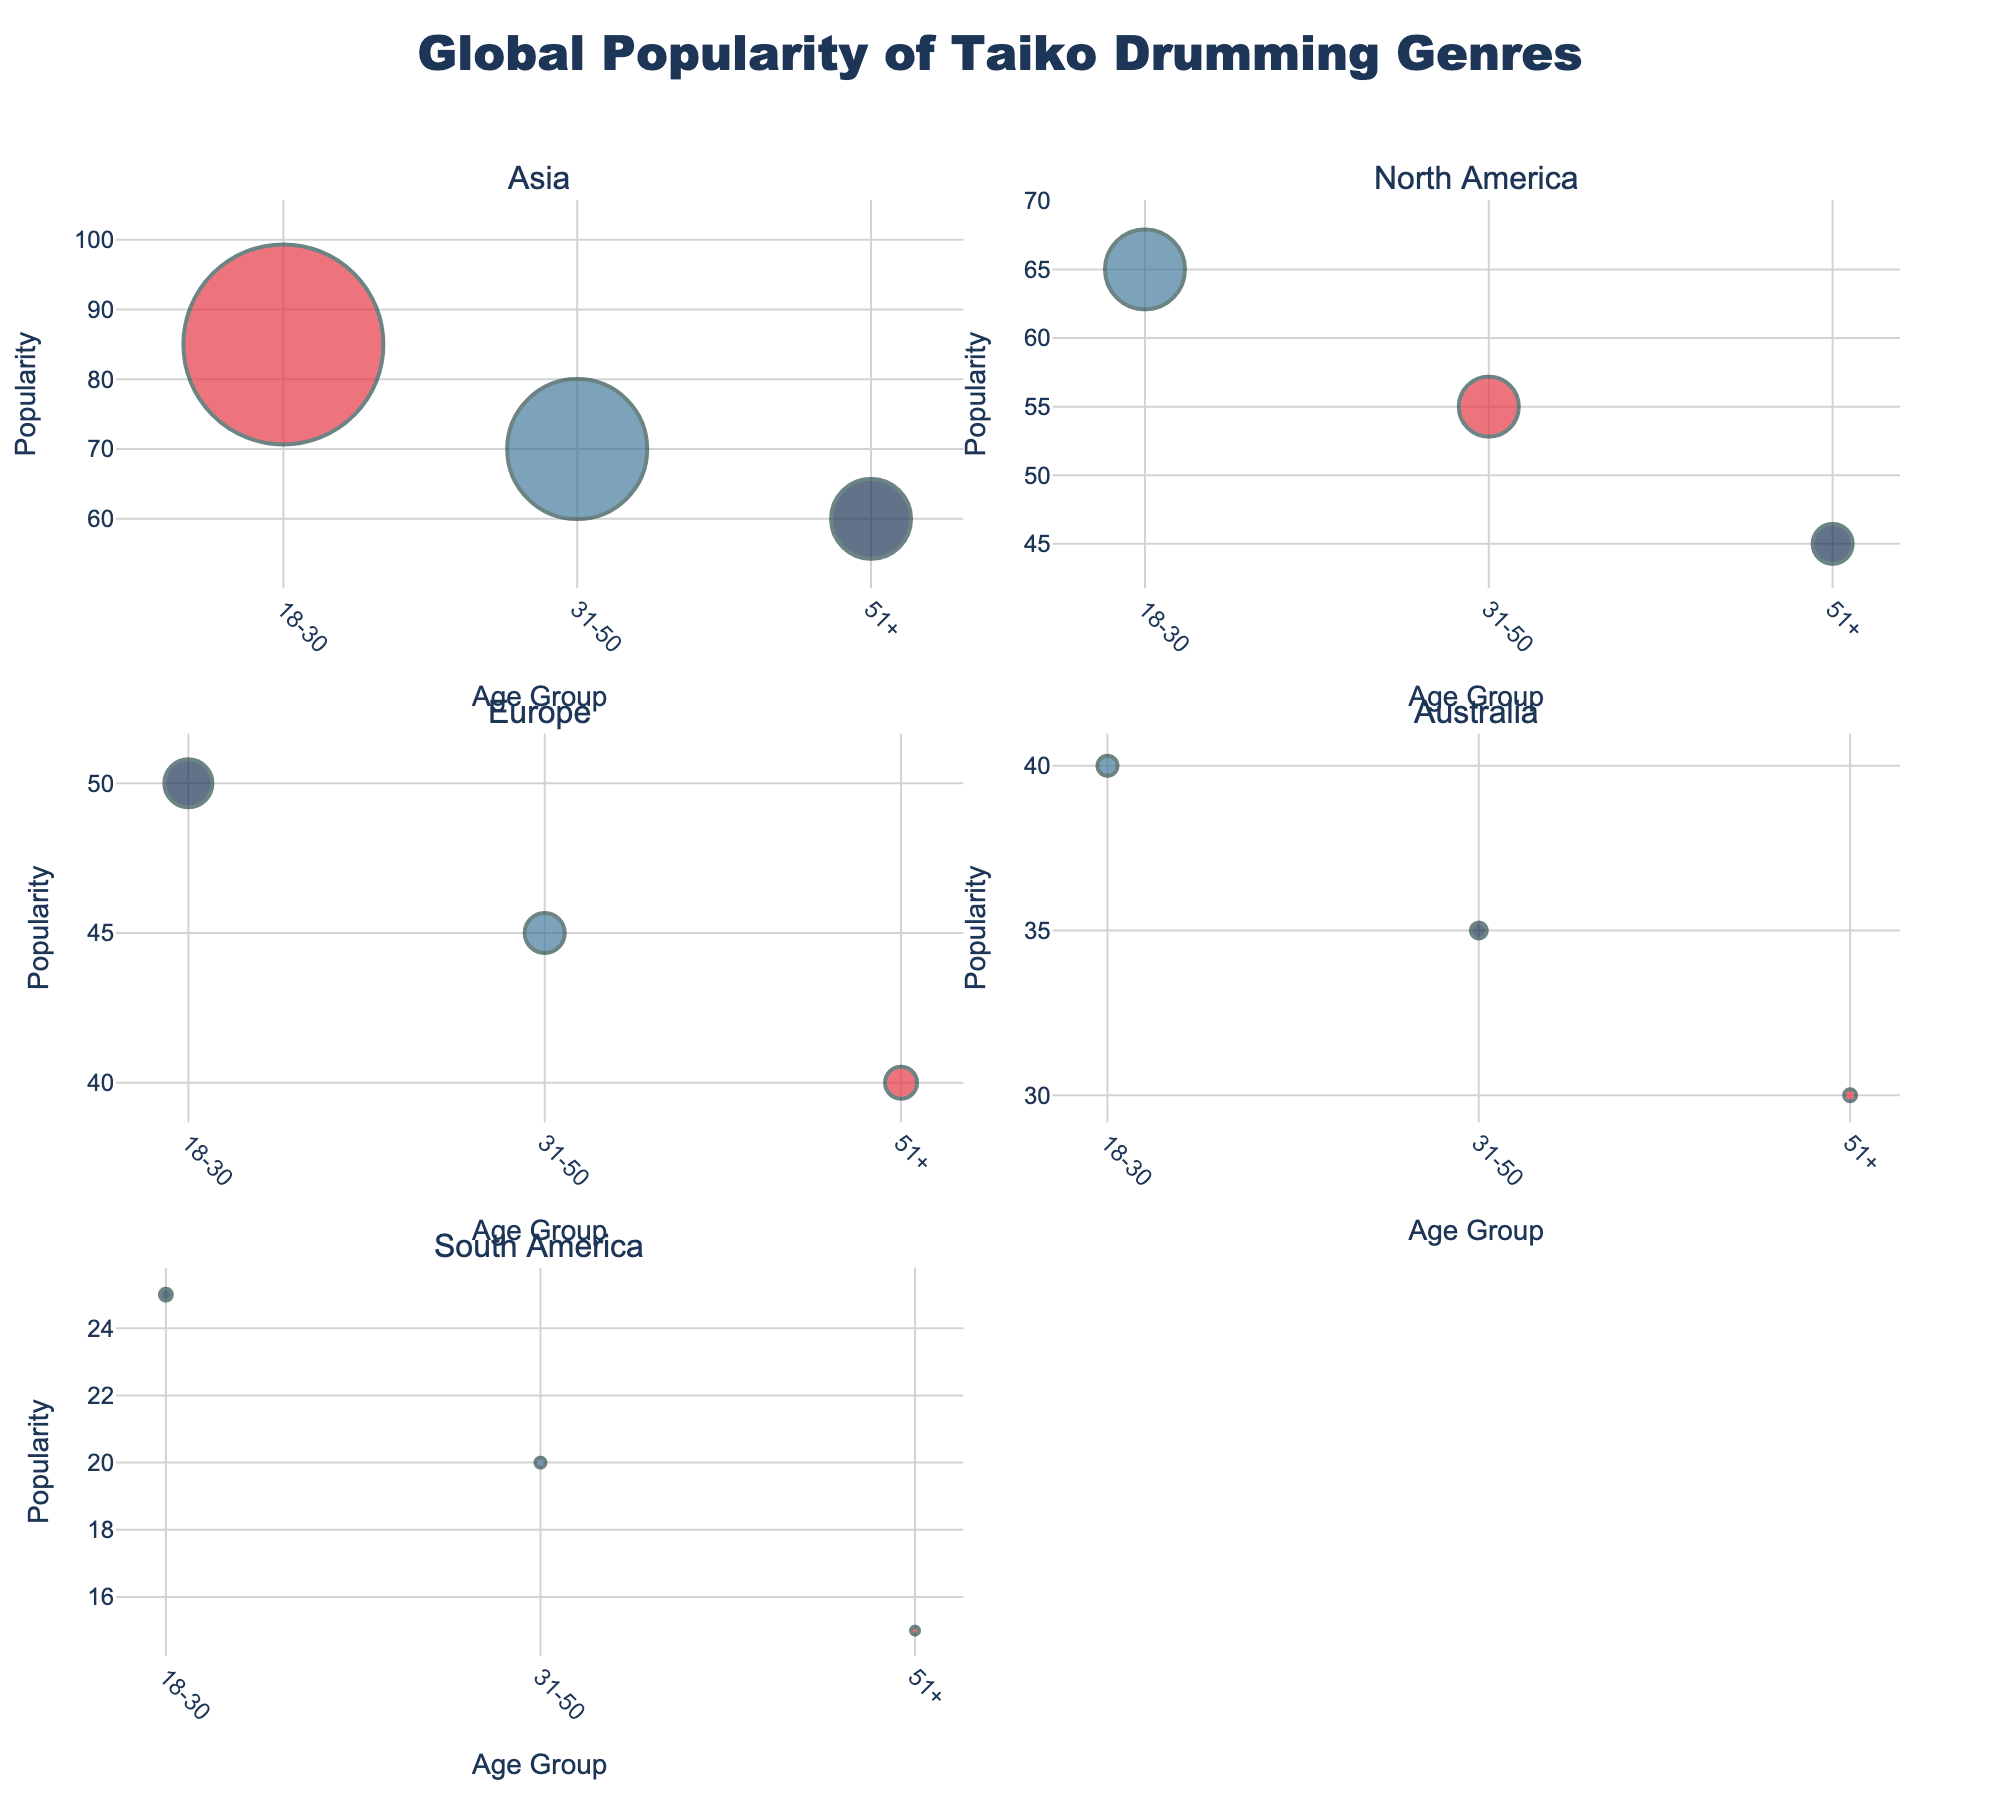What is the most popular taiko drumming genre among the 18-30 age group in Asia? The highest bubble in Asia for the 18-30 age group is marked with the color representing Traditional Taiko, with a popularity score of 85.
Answer: Traditional Taiko Which continent has the least popular taiko genre for the 51+ age group? The smallest bubble among the 51+ age groups is in South America with a popularity score of 15 for Traditional Taiko.
Answer: South America In which age group and continent is Fusion Taiko more popular than both Traditional Taiko and Contemporary Taiko? In the plot for North America for the 18-30 age group, Fusion Taiko is more popular than both Traditional Taiko and Contemporary Taiko, with a popularity score of 65.
Answer: North America, 18-30 How does the popularity of Traditional Taiko compare between Europe and Australia for the 31-50 age group? In the subplot for Europe for the 31-50 age group, Traditional Taiko is not present; however, in Australia, it has a popularity score of 30.
Answer: Higher in Europe What is the average audience size for all taiko genres in Asia? Summing the all audience sizes in Asia (5000000 + 3500000 + 2000000) gives 10500000, and averaging this by 3 gives: 10500000 / 3.
Answer: 3500000 Identify the continent where Contemporary Taiko is the most popular among all age groups. The highest bubble for Contemporary Taiko across all subplots is in Asia for the 51+ age group, with a popularity score of 60.
Answer: Asia How does the popularity of Fusion Taiko in North America compare to Asia among 31-50 age group? In North America, Fusion Taiko has a popularity score of 55, while in Asia it has 70. Hence, Fusion Taiko is more popular in Asia.
Answer: More popular in Asia What are the color codes used to represent each taiko genre? Traditional Taiko is represented by red, Fusion Taiko by blue, and Contemporary Taiko by dark blue.
Answer: Red, Blue, Dark Blue 